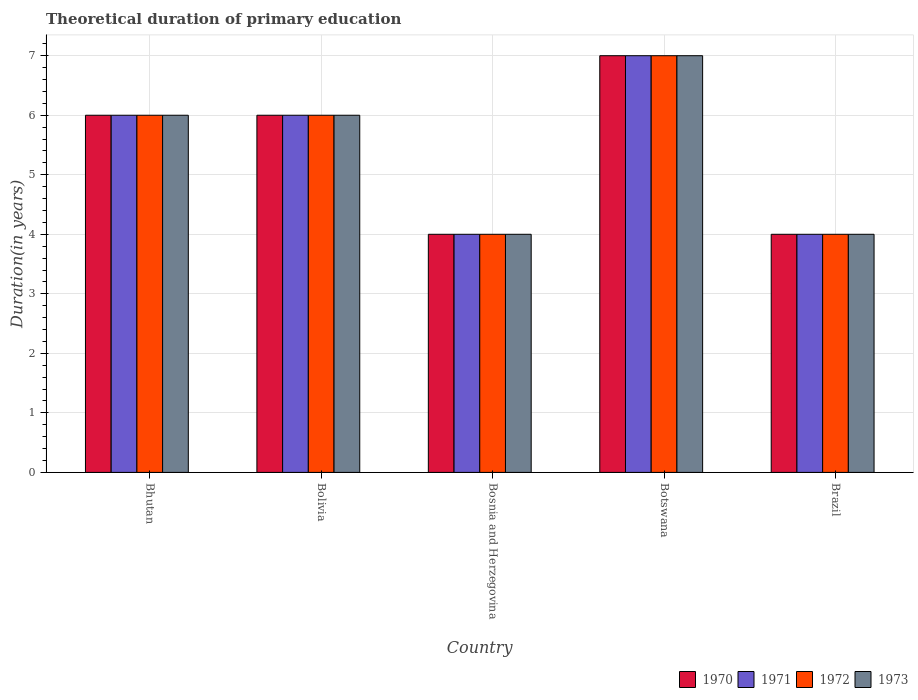How many different coloured bars are there?
Ensure brevity in your answer.  4. Are the number of bars on each tick of the X-axis equal?
Your answer should be compact. Yes. How many bars are there on the 5th tick from the right?
Ensure brevity in your answer.  4. What is the total theoretical duration of primary education in 1970 in Botswana?
Your answer should be very brief. 7. Across all countries, what is the minimum total theoretical duration of primary education in 1970?
Give a very brief answer. 4. In which country was the total theoretical duration of primary education in 1971 maximum?
Your answer should be very brief. Botswana. In which country was the total theoretical duration of primary education in 1971 minimum?
Your answer should be very brief. Bosnia and Herzegovina. What is the difference between the total theoretical duration of primary education in 1970 in Bolivia and that in Botswana?
Your answer should be very brief. -1. What is the average total theoretical duration of primary education in 1973 per country?
Your answer should be compact. 5.4. In how many countries, is the total theoretical duration of primary education in 1971 greater than 1 years?
Keep it short and to the point. 5. What is the ratio of the total theoretical duration of primary education in 1971 in Bhutan to that in Bolivia?
Offer a very short reply. 1. Is the total theoretical duration of primary education in 1971 in Bosnia and Herzegovina less than that in Brazil?
Keep it short and to the point. No. Is the difference between the total theoretical duration of primary education in 1972 in Bosnia and Herzegovina and Botswana greater than the difference between the total theoretical duration of primary education in 1971 in Bosnia and Herzegovina and Botswana?
Give a very brief answer. No. What is the difference between the highest and the second highest total theoretical duration of primary education in 1971?
Ensure brevity in your answer.  -1. What is the difference between the highest and the lowest total theoretical duration of primary education in 1971?
Keep it short and to the point. 3. In how many countries, is the total theoretical duration of primary education in 1972 greater than the average total theoretical duration of primary education in 1972 taken over all countries?
Provide a short and direct response. 3. Are all the bars in the graph horizontal?
Give a very brief answer. No. How many countries are there in the graph?
Offer a terse response. 5. Are the values on the major ticks of Y-axis written in scientific E-notation?
Give a very brief answer. No. Does the graph contain any zero values?
Provide a short and direct response. No. Where does the legend appear in the graph?
Make the answer very short. Bottom right. How many legend labels are there?
Your answer should be compact. 4. What is the title of the graph?
Offer a very short reply. Theoretical duration of primary education. What is the label or title of the Y-axis?
Ensure brevity in your answer.  Duration(in years). What is the Duration(in years) in 1970 in Bhutan?
Provide a succinct answer. 6. What is the Duration(in years) in 1971 in Bhutan?
Provide a short and direct response. 6. What is the Duration(in years) of 1973 in Bhutan?
Your answer should be compact. 6. What is the Duration(in years) of 1970 in Bolivia?
Make the answer very short. 6. What is the Duration(in years) in 1971 in Bolivia?
Ensure brevity in your answer.  6. What is the Duration(in years) in 1972 in Bolivia?
Keep it short and to the point. 6. What is the Duration(in years) of 1971 in Bosnia and Herzegovina?
Keep it short and to the point. 4. What is the Duration(in years) in 1973 in Bosnia and Herzegovina?
Offer a very short reply. 4. What is the Duration(in years) in 1970 in Botswana?
Provide a short and direct response. 7. What is the Duration(in years) of 1973 in Botswana?
Offer a very short reply. 7. What is the Duration(in years) of 1971 in Brazil?
Your answer should be very brief. 4. What is the Duration(in years) of 1972 in Brazil?
Your response must be concise. 4. Across all countries, what is the maximum Duration(in years) of 1971?
Your answer should be very brief. 7. Across all countries, what is the maximum Duration(in years) in 1972?
Offer a terse response. 7. Across all countries, what is the maximum Duration(in years) in 1973?
Give a very brief answer. 7. Across all countries, what is the minimum Duration(in years) of 1970?
Provide a succinct answer. 4. Across all countries, what is the minimum Duration(in years) in 1972?
Give a very brief answer. 4. Across all countries, what is the minimum Duration(in years) in 1973?
Your answer should be compact. 4. What is the total Duration(in years) in 1970 in the graph?
Offer a very short reply. 27. What is the total Duration(in years) in 1972 in the graph?
Your response must be concise. 27. What is the total Duration(in years) in 1973 in the graph?
Offer a very short reply. 27. What is the difference between the Duration(in years) of 1970 in Bhutan and that in Bolivia?
Keep it short and to the point. 0. What is the difference between the Duration(in years) in 1972 in Bhutan and that in Bolivia?
Your response must be concise. 0. What is the difference between the Duration(in years) in 1970 in Bhutan and that in Bosnia and Herzegovina?
Ensure brevity in your answer.  2. What is the difference between the Duration(in years) of 1973 in Bhutan and that in Bosnia and Herzegovina?
Give a very brief answer. 2. What is the difference between the Duration(in years) of 1970 in Bhutan and that in Botswana?
Make the answer very short. -1. What is the difference between the Duration(in years) in 1972 in Bhutan and that in Botswana?
Make the answer very short. -1. What is the difference between the Duration(in years) of 1973 in Bhutan and that in Botswana?
Your answer should be compact. -1. What is the difference between the Duration(in years) in 1973 in Bhutan and that in Brazil?
Ensure brevity in your answer.  2. What is the difference between the Duration(in years) in 1970 in Bolivia and that in Bosnia and Herzegovina?
Keep it short and to the point. 2. What is the difference between the Duration(in years) in 1971 in Bolivia and that in Bosnia and Herzegovina?
Your answer should be compact. 2. What is the difference between the Duration(in years) in 1973 in Bolivia and that in Bosnia and Herzegovina?
Your answer should be very brief. 2. What is the difference between the Duration(in years) in 1970 in Bolivia and that in Botswana?
Keep it short and to the point. -1. What is the difference between the Duration(in years) in 1971 in Bolivia and that in Botswana?
Your answer should be compact. -1. What is the difference between the Duration(in years) in 1970 in Bolivia and that in Brazil?
Ensure brevity in your answer.  2. What is the difference between the Duration(in years) of 1972 in Bosnia and Herzegovina and that in Brazil?
Provide a short and direct response. 0. What is the difference between the Duration(in years) in 1970 in Botswana and that in Brazil?
Keep it short and to the point. 3. What is the difference between the Duration(in years) of 1971 in Botswana and that in Brazil?
Give a very brief answer. 3. What is the difference between the Duration(in years) in 1972 in Botswana and that in Brazil?
Your answer should be very brief. 3. What is the difference between the Duration(in years) in 1973 in Botswana and that in Brazil?
Provide a short and direct response. 3. What is the difference between the Duration(in years) of 1970 in Bhutan and the Duration(in years) of 1971 in Bolivia?
Keep it short and to the point. 0. What is the difference between the Duration(in years) in 1970 in Bhutan and the Duration(in years) in 1972 in Bolivia?
Keep it short and to the point. 0. What is the difference between the Duration(in years) in 1970 in Bhutan and the Duration(in years) in 1973 in Bolivia?
Offer a very short reply. 0. What is the difference between the Duration(in years) of 1971 in Bhutan and the Duration(in years) of 1972 in Bosnia and Herzegovina?
Keep it short and to the point. 2. What is the difference between the Duration(in years) in 1972 in Bhutan and the Duration(in years) in 1973 in Bosnia and Herzegovina?
Make the answer very short. 2. What is the difference between the Duration(in years) in 1970 in Bhutan and the Duration(in years) in 1972 in Botswana?
Offer a very short reply. -1. What is the difference between the Duration(in years) in 1970 in Bhutan and the Duration(in years) in 1973 in Botswana?
Keep it short and to the point. -1. What is the difference between the Duration(in years) of 1971 in Bhutan and the Duration(in years) of 1973 in Botswana?
Your answer should be very brief. -1. What is the difference between the Duration(in years) in 1972 in Bhutan and the Duration(in years) in 1973 in Botswana?
Give a very brief answer. -1. What is the difference between the Duration(in years) of 1971 in Bhutan and the Duration(in years) of 1972 in Brazil?
Your response must be concise. 2. What is the difference between the Duration(in years) in 1971 in Bhutan and the Duration(in years) in 1973 in Brazil?
Your answer should be compact. 2. What is the difference between the Duration(in years) of 1970 in Bolivia and the Duration(in years) of 1971 in Bosnia and Herzegovina?
Your response must be concise. 2. What is the difference between the Duration(in years) in 1970 in Bolivia and the Duration(in years) in 1973 in Bosnia and Herzegovina?
Provide a succinct answer. 2. What is the difference between the Duration(in years) of 1971 in Bolivia and the Duration(in years) of 1973 in Bosnia and Herzegovina?
Offer a terse response. 2. What is the difference between the Duration(in years) in 1970 in Bolivia and the Duration(in years) in 1972 in Botswana?
Provide a succinct answer. -1. What is the difference between the Duration(in years) of 1970 in Bolivia and the Duration(in years) of 1973 in Botswana?
Offer a terse response. -1. What is the difference between the Duration(in years) of 1971 in Bolivia and the Duration(in years) of 1972 in Botswana?
Your response must be concise. -1. What is the difference between the Duration(in years) of 1972 in Bolivia and the Duration(in years) of 1973 in Botswana?
Your response must be concise. -1. What is the difference between the Duration(in years) in 1970 in Bolivia and the Duration(in years) in 1971 in Brazil?
Ensure brevity in your answer.  2. What is the difference between the Duration(in years) in 1970 in Bolivia and the Duration(in years) in 1972 in Brazil?
Give a very brief answer. 2. What is the difference between the Duration(in years) in 1970 in Bolivia and the Duration(in years) in 1973 in Brazil?
Provide a succinct answer. 2. What is the difference between the Duration(in years) of 1971 in Bolivia and the Duration(in years) of 1972 in Brazil?
Offer a very short reply. 2. What is the difference between the Duration(in years) of 1971 in Bolivia and the Duration(in years) of 1973 in Brazil?
Your answer should be very brief. 2. What is the difference between the Duration(in years) in 1970 in Bosnia and Herzegovina and the Duration(in years) in 1973 in Botswana?
Make the answer very short. -3. What is the difference between the Duration(in years) in 1971 in Bosnia and Herzegovina and the Duration(in years) in 1973 in Botswana?
Keep it short and to the point. -3. What is the difference between the Duration(in years) in 1972 in Bosnia and Herzegovina and the Duration(in years) in 1973 in Botswana?
Give a very brief answer. -3. What is the difference between the Duration(in years) in 1970 in Bosnia and Herzegovina and the Duration(in years) in 1972 in Brazil?
Offer a terse response. 0. What is the difference between the Duration(in years) in 1970 in Bosnia and Herzegovina and the Duration(in years) in 1973 in Brazil?
Your answer should be compact. 0. What is the difference between the Duration(in years) in 1971 in Bosnia and Herzegovina and the Duration(in years) in 1972 in Brazil?
Keep it short and to the point. 0. What is the difference between the Duration(in years) of 1970 in Botswana and the Duration(in years) of 1971 in Brazil?
Your answer should be compact. 3. What is the difference between the Duration(in years) in 1970 in Botswana and the Duration(in years) in 1972 in Brazil?
Your answer should be very brief. 3. What is the difference between the Duration(in years) of 1971 in Botswana and the Duration(in years) of 1972 in Brazil?
Ensure brevity in your answer.  3. What is the difference between the Duration(in years) of 1971 in Botswana and the Duration(in years) of 1973 in Brazil?
Your answer should be very brief. 3. What is the difference between the Duration(in years) of 1972 in Botswana and the Duration(in years) of 1973 in Brazil?
Make the answer very short. 3. What is the average Duration(in years) of 1971 per country?
Keep it short and to the point. 5.4. What is the average Duration(in years) in 1973 per country?
Your answer should be compact. 5.4. What is the difference between the Duration(in years) of 1970 and Duration(in years) of 1972 in Bhutan?
Offer a very short reply. 0. What is the difference between the Duration(in years) of 1970 and Duration(in years) of 1972 in Bolivia?
Make the answer very short. 0. What is the difference between the Duration(in years) in 1971 and Duration(in years) in 1973 in Bolivia?
Offer a very short reply. 0. What is the difference between the Duration(in years) of 1972 and Duration(in years) of 1973 in Bolivia?
Provide a succinct answer. 0. What is the difference between the Duration(in years) of 1970 and Duration(in years) of 1971 in Bosnia and Herzegovina?
Make the answer very short. 0. What is the difference between the Duration(in years) in 1970 and Duration(in years) in 1973 in Bosnia and Herzegovina?
Your answer should be very brief. 0. What is the difference between the Duration(in years) in 1971 and Duration(in years) in 1973 in Bosnia and Herzegovina?
Make the answer very short. 0. What is the difference between the Duration(in years) in 1972 and Duration(in years) in 1973 in Bosnia and Herzegovina?
Offer a very short reply. 0. What is the difference between the Duration(in years) of 1970 and Duration(in years) of 1971 in Botswana?
Your answer should be very brief. 0. What is the difference between the Duration(in years) in 1970 and Duration(in years) in 1972 in Botswana?
Provide a short and direct response. 0. What is the difference between the Duration(in years) of 1970 and Duration(in years) of 1973 in Botswana?
Ensure brevity in your answer.  0. What is the difference between the Duration(in years) in 1971 and Duration(in years) in 1972 in Botswana?
Your answer should be compact. 0. What is the difference between the Duration(in years) in 1970 and Duration(in years) in 1971 in Brazil?
Provide a succinct answer. 0. What is the difference between the Duration(in years) of 1970 and Duration(in years) of 1973 in Brazil?
Give a very brief answer. 0. What is the difference between the Duration(in years) in 1971 and Duration(in years) in 1972 in Brazil?
Offer a very short reply. 0. What is the difference between the Duration(in years) in 1972 and Duration(in years) in 1973 in Brazil?
Your response must be concise. 0. What is the ratio of the Duration(in years) of 1971 in Bhutan to that in Bolivia?
Give a very brief answer. 1. What is the ratio of the Duration(in years) in 1970 in Bhutan to that in Botswana?
Your answer should be very brief. 0.86. What is the ratio of the Duration(in years) of 1971 in Bhutan to that in Botswana?
Provide a succinct answer. 0.86. What is the ratio of the Duration(in years) in 1972 in Bhutan to that in Botswana?
Provide a short and direct response. 0.86. What is the ratio of the Duration(in years) of 1973 in Bhutan to that in Botswana?
Your response must be concise. 0.86. What is the ratio of the Duration(in years) in 1972 in Bhutan to that in Brazil?
Your answer should be compact. 1.5. What is the ratio of the Duration(in years) in 1973 in Bhutan to that in Brazil?
Ensure brevity in your answer.  1.5. What is the ratio of the Duration(in years) in 1972 in Bolivia to that in Bosnia and Herzegovina?
Give a very brief answer. 1.5. What is the ratio of the Duration(in years) in 1973 in Bolivia to that in Bosnia and Herzegovina?
Your answer should be compact. 1.5. What is the ratio of the Duration(in years) of 1971 in Bolivia to that in Botswana?
Give a very brief answer. 0.86. What is the ratio of the Duration(in years) of 1970 in Bolivia to that in Brazil?
Your answer should be very brief. 1.5. What is the ratio of the Duration(in years) in 1971 in Bolivia to that in Brazil?
Keep it short and to the point. 1.5. What is the ratio of the Duration(in years) of 1972 in Bolivia to that in Brazil?
Keep it short and to the point. 1.5. What is the ratio of the Duration(in years) in 1973 in Bolivia to that in Brazil?
Provide a short and direct response. 1.5. What is the ratio of the Duration(in years) of 1971 in Bosnia and Herzegovina to that in Botswana?
Your answer should be compact. 0.57. What is the ratio of the Duration(in years) in 1973 in Bosnia and Herzegovina to that in Botswana?
Give a very brief answer. 0.57. What is the ratio of the Duration(in years) of 1972 in Bosnia and Herzegovina to that in Brazil?
Your answer should be very brief. 1. What is the ratio of the Duration(in years) in 1973 in Bosnia and Herzegovina to that in Brazil?
Provide a short and direct response. 1. What is the ratio of the Duration(in years) in 1970 in Botswana to that in Brazil?
Give a very brief answer. 1.75. What is the ratio of the Duration(in years) in 1971 in Botswana to that in Brazil?
Your response must be concise. 1.75. What is the ratio of the Duration(in years) of 1972 in Botswana to that in Brazil?
Your response must be concise. 1.75. What is the ratio of the Duration(in years) in 1973 in Botswana to that in Brazil?
Offer a terse response. 1.75. What is the difference between the highest and the second highest Duration(in years) of 1970?
Make the answer very short. 1. What is the difference between the highest and the second highest Duration(in years) in 1972?
Provide a succinct answer. 1. What is the difference between the highest and the second highest Duration(in years) in 1973?
Your answer should be very brief. 1. What is the difference between the highest and the lowest Duration(in years) of 1970?
Your response must be concise. 3. What is the difference between the highest and the lowest Duration(in years) of 1972?
Provide a succinct answer. 3. 